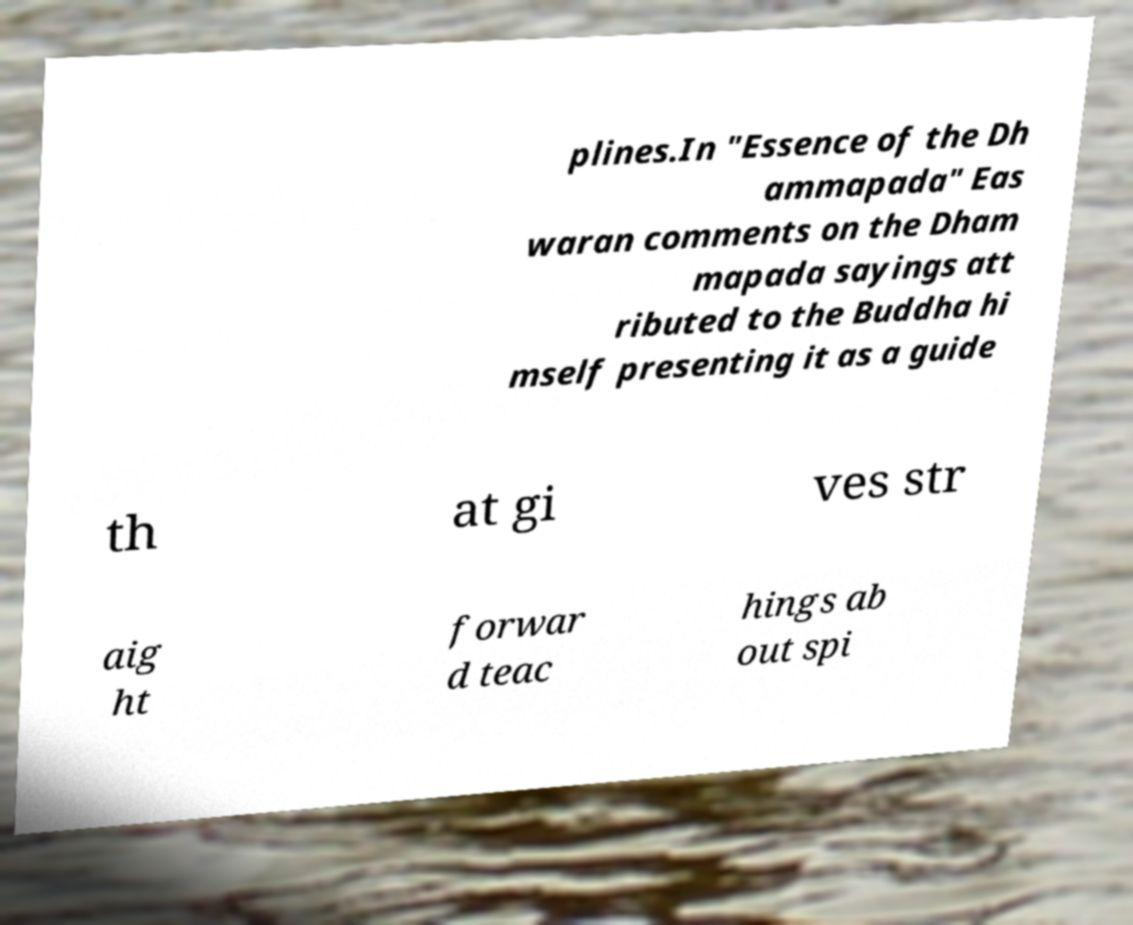Can you read and provide the text displayed in the image?This photo seems to have some interesting text. Can you extract and type it out for me? plines.In "Essence of the Dh ammapada" Eas waran comments on the Dham mapada sayings att ributed to the Buddha hi mself presenting it as a guide th at gi ves str aig ht forwar d teac hings ab out spi 